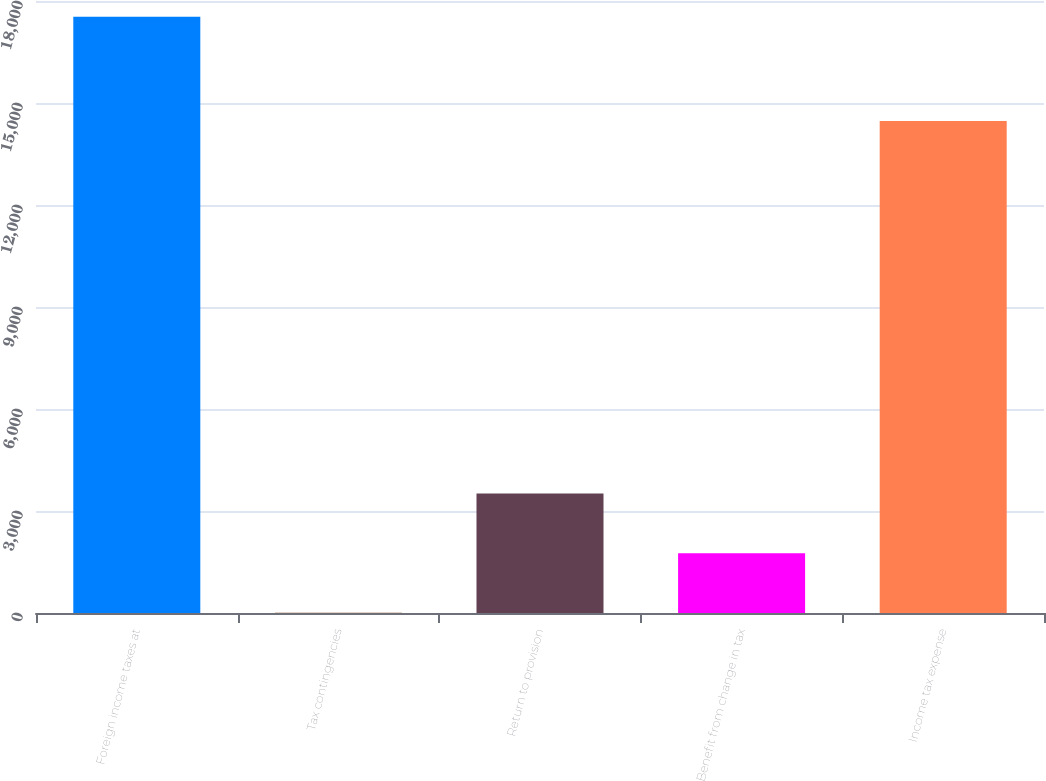Convert chart. <chart><loc_0><loc_0><loc_500><loc_500><bar_chart><fcel>Foreign income taxes at<fcel>Tax contingencies<fcel>Return to provision<fcel>Benefit from change in tax<fcel>Income tax expense<nl><fcel>17540<fcel>5<fcel>3512<fcel>1758.5<fcel>14467<nl></chart> 